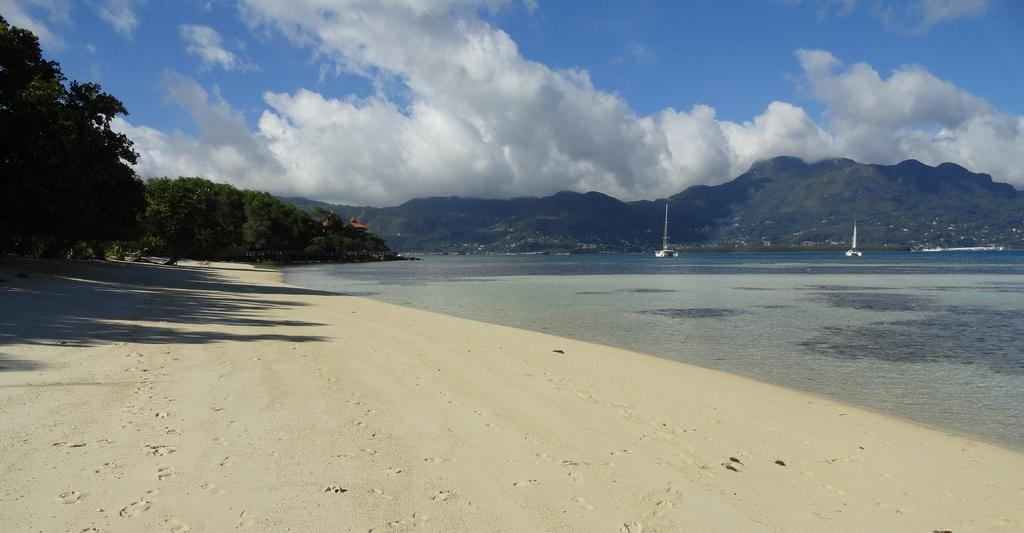What is in the water in the image? There are boats in the water in the image. What can be seen in the background of the image? There is a mountain and the sky visible in the background. What type of vegetation is on the left side of the image? There are trees on the left side of the image. What is visible on the ground in the image? Shadows are present on the ground in the image. What type of education is being taught in the boats in the image? There is no indication of education being taught in the boats in the image. What design elements can be seen in the mountain in the image? There are no design elements mentioned in the facts, and the mountain is not the focus of the image. 